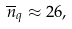<formula> <loc_0><loc_0><loc_500><loc_500>\overline { n } _ { q } \approx 2 6 ,</formula> 